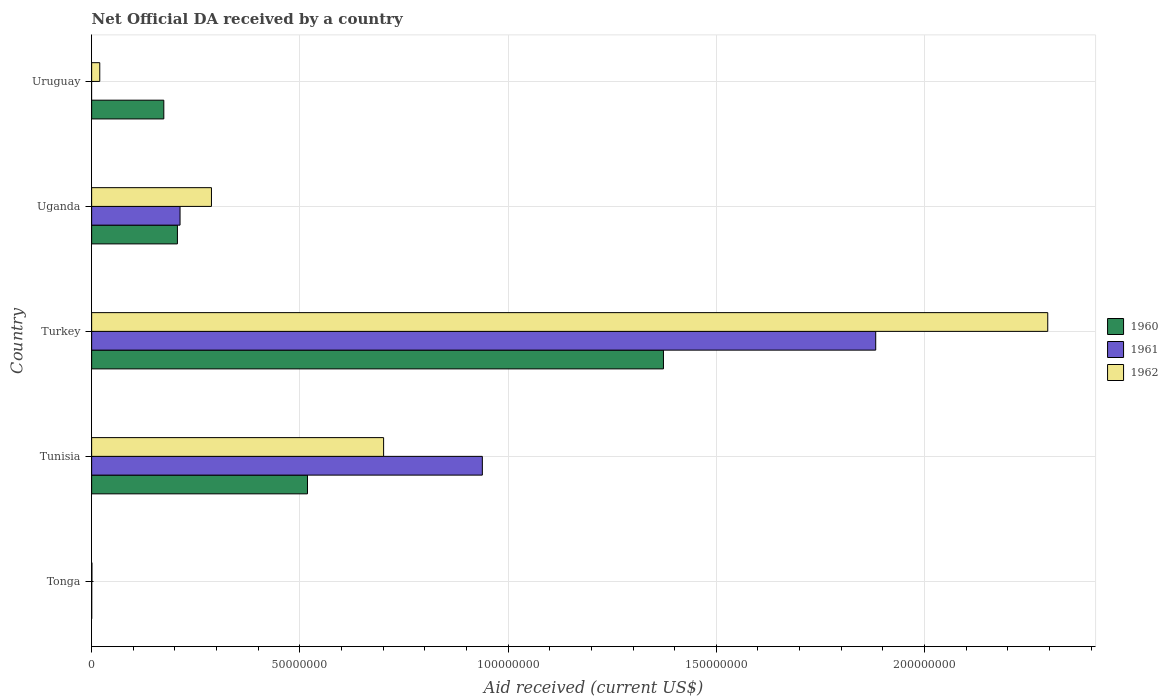Are the number of bars per tick equal to the number of legend labels?
Keep it short and to the point. No. Are the number of bars on each tick of the Y-axis equal?
Give a very brief answer. No. How many bars are there on the 2nd tick from the bottom?
Offer a very short reply. 3. What is the label of the 1st group of bars from the top?
Provide a succinct answer. Uruguay. What is the net official development assistance aid received in 1961 in Tunisia?
Keep it short and to the point. 9.38e+07. Across all countries, what is the maximum net official development assistance aid received in 1961?
Offer a terse response. 1.88e+08. Across all countries, what is the minimum net official development assistance aid received in 1960?
Offer a very short reply. 10000. In which country was the net official development assistance aid received in 1961 maximum?
Your answer should be compact. Turkey. What is the total net official development assistance aid received in 1962 in the graph?
Keep it short and to the point. 3.30e+08. What is the difference between the net official development assistance aid received in 1962 in Turkey and that in Uruguay?
Provide a succinct answer. 2.28e+08. What is the difference between the net official development assistance aid received in 1961 in Uganda and the net official development assistance aid received in 1962 in Turkey?
Provide a short and direct response. -2.08e+08. What is the average net official development assistance aid received in 1962 per country?
Provide a short and direct response. 6.61e+07. What is the ratio of the net official development assistance aid received in 1960 in Tunisia to that in Uganda?
Provide a succinct answer. 2.52. Is the net official development assistance aid received in 1960 in Tunisia less than that in Uganda?
Make the answer very short. No. What is the difference between the highest and the second highest net official development assistance aid received in 1962?
Your answer should be very brief. 1.59e+08. What is the difference between the highest and the lowest net official development assistance aid received in 1960?
Ensure brevity in your answer.  1.37e+08. In how many countries, is the net official development assistance aid received in 1961 greater than the average net official development assistance aid received in 1961 taken over all countries?
Your answer should be compact. 2. Is it the case that in every country, the sum of the net official development assistance aid received in 1961 and net official development assistance aid received in 1960 is greater than the net official development assistance aid received in 1962?
Provide a short and direct response. No. How many bars are there?
Provide a succinct answer. 14. Are all the bars in the graph horizontal?
Your response must be concise. Yes. What is the difference between two consecutive major ticks on the X-axis?
Provide a short and direct response. 5.00e+07. Where does the legend appear in the graph?
Provide a short and direct response. Center right. How many legend labels are there?
Ensure brevity in your answer.  3. How are the legend labels stacked?
Your response must be concise. Vertical. What is the title of the graph?
Ensure brevity in your answer.  Net Official DA received by a country. Does "1969" appear as one of the legend labels in the graph?
Give a very brief answer. No. What is the label or title of the X-axis?
Give a very brief answer. Aid received (current US$). What is the Aid received (current US$) in 1961 in Tonga?
Offer a very short reply. 2.00e+04. What is the Aid received (current US$) of 1960 in Tunisia?
Give a very brief answer. 5.18e+07. What is the Aid received (current US$) of 1961 in Tunisia?
Offer a very short reply. 9.38e+07. What is the Aid received (current US$) in 1962 in Tunisia?
Provide a succinct answer. 7.01e+07. What is the Aid received (current US$) of 1960 in Turkey?
Your answer should be compact. 1.37e+08. What is the Aid received (current US$) of 1961 in Turkey?
Your response must be concise. 1.88e+08. What is the Aid received (current US$) in 1962 in Turkey?
Offer a terse response. 2.30e+08. What is the Aid received (current US$) in 1960 in Uganda?
Your response must be concise. 2.06e+07. What is the Aid received (current US$) in 1961 in Uganda?
Ensure brevity in your answer.  2.12e+07. What is the Aid received (current US$) of 1962 in Uganda?
Give a very brief answer. 2.88e+07. What is the Aid received (current US$) in 1960 in Uruguay?
Make the answer very short. 1.73e+07. What is the Aid received (current US$) in 1961 in Uruguay?
Provide a succinct answer. 0. What is the Aid received (current US$) in 1962 in Uruguay?
Provide a short and direct response. 1.95e+06. Across all countries, what is the maximum Aid received (current US$) of 1960?
Provide a short and direct response. 1.37e+08. Across all countries, what is the maximum Aid received (current US$) of 1961?
Give a very brief answer. 1.88e+08. Across all countries, what is the maximum Aid received (current US$) in 1962?
Provide a succinct answer. 2.30e+08. Across all countries, what is the minimum Aid received (current US$) in 1960?
Your response must be concise. 10000. Across all countries, what is the minimum Aid received (current US$) in 1962?
Provide a succinct answer. 7.00e+04. What is the total Aid received (current US$) in 1960 in the graph?
Offer a terse response. 2.27e+08. What is the total Aid received (current US$) in 1961 in the graph?
Keep it short and to the point. 3.03e+08. What is the total Aid received (current US$) of 1962 in the graph?
Ensure brevity in your answer.  3.30e+08. What is the difference between the Aid received (current US$) of 1960 in Tonga and that in Tunisia?
Keep it short and to the point. -5.18e+07. What is the difference between the Aid received (current US$) of 1961 in Tonga and that in Tunisia?
Provide a succinct answer. -9.38e+07. What is the difference between the Aid received (current US$) in 1962 in Tonga and that in Tunisia?
Your answer should be compact. -7.00e+07. What is the difference between the Aid received (current US$) in 1960 in Tonga and that in Turkey?
Keep it short and to the point. -1.37e+08. What is the difference between the Aid received (current US$) in 1961 in Tonga and that in Turkey?
Offer a terse response. -1.88e+08. What is the difference between the Aid received (current US$) in 1962 in Tonga and that in Turkey?
Provide a short and direct response. -2.30e+08. What is the difference between the Aid received (current US$) of 1960 in Tonga and that in Uganda?
Offer a very short reply. -2.06e+07. What is the difference between the Aid received (current US$) in 1961 in Tonga and that in Uganda?
Offer a very short reply. -2.12e+07. What is the difference between the Aid received (current US$) of 1962 in Tonga and that in Uganda?
Your response must be concise. -2.87e+07. What is the difference between the Aid received (current US$) in 1960 in Tonga and that in Uruguay?
Your answer should be very brief. -1.73e+07. What is the difference between the Aid received (current US$) of 1962 in Tonga and that in Uruguay?
Keep it short and to the point. -1.88e+06. What is the difference between the Aid received (current US$) of 1960 in Tunisia and that in Turkey?
Make the answer very short. -8.55e+07. What is the difference between the Aid received (current US$) of 1961 in Tunisia and that in Turkey?
Offer a terse response. -9.45e+07. What is the difference between the Aid received (current US$) in 1962 in Tunisia and that in Turkey?
Offer a very short reply. -1.59e+08. What is the difference between the Aid received (current US$) in 1960 in Tunisia and that in Uganda?
Provide a short and direct response. 3.12e+07. What is the difference between the Aid received (current US$) in 1961 in Tunisia and that in Uganda?
Offer a terse response. 7.26e+07. What is the difference between the Aid received (current US$) of 1962 in Tunisia and that in Uganda?
Keep it short and to the point. 4.13e+07. What is the difference between the Aid received (current US$) of 1960 in Tunisia and that in Uruguay?
Your answer should be compact. 3.45e+07. What is the difference between the Aid received (current US$) of 1962 in Tunisia and that in Uruguay?
Provide a short and direct response. 6.82e+07. What is the difference between the Aid received (current US$) in 1960 in Turkey and that in Uganda?
Ensure brevity in your answer.  1.17e+08. What is the difference between the Aid received (current US$) in 1961 in Turkey and that in Uganda?
Provide a succinct answer. 1.67e+08. What is the difference between the Aid received (current US$) of 1962 in Turkey and that in Uganda?
Your response must be concise. 2.01e+08. What is the difference between the Aid received (current US$) of 1960 in Turkey and that in Uruguay?
Offer a very short reply. 1.20e+08. What is the difference between the Aid received (current US$) in 1962 in Turkey and that in Uruguay?
Ensure brevity in your answer.  2.28e+08. What is the difference between the Aid received (current US$) of 1960 in Uganda and that in Uruguay?
Your answer should be very brief. 3.27e+06. What is the difference between the Aid received (current US$) in 1962 in Uganda and that in Uruguay?
Provide a succinct answer. 2.68e+07. What is the difference between the Aid received (current US$) of 1960 in Tonga and the Aid received (current US$) of 1961 in Tunisia?
Your answer should be very brief. -9.38e+07. What is the difference between the Aid received (current US$) in 1960 in Tonga and the Aid received (current US$) in 1962 in Tunisia?
Make the answer very short. -7.01e+07. What is the difference between the Aid received (current US$) of 1961 in Tonga and the Aid received (current US$) of 1962 in Tunisia?
Offer a very short reply. -7.01e+07. What is the difference between the Aid received (current US$) in 1960 in Tonga and the Aid received (current US$) in 1961 in Turkey?
Your response must be concise. -1.88e+08. What is the difference between the Aid received (current US$) of 1960 in Tonga and the Aid received (current US$) of 1962 in Turkey?
Your answer should be very brief. -2.30e+08. What is the difference between the Aid received (current US$) in 1961 in Tonga and the Aid received (current US$) in 1962 in Turkey?
Your response must be concise. -2.30e+08. What is the difference between the Aid received (current US$) in 1960 in Tonga and the Aid received (current US$) in 1961 in Uganda?
Your answer should be compact. -2.12e+07. What is the difference between the Aid received (current US$) in 1960 in Tonga and the Aid received (current US$) in 1962 in Uganda?
Provide a short and direct response. -2.88e+07. What is the difference between the Aid received (current US$) in 1961 in Tonga and the Aid received (current US$) in 1962 in Uganda?
Provide a succinct answer. -2.88e+07. What is the difference between the Aid received (current US$) of 1960 in Tonga and the Aid received (current US$) of 1962 in Uruguay?
Your response must be concise. -1.94e+06. What is the difference between the Aid received (current US$) of 1961 in Tonga and the Aid received (current US$) of 1962 in Uruguay?
Ensure brevity in your answer.  -1.93e+06. What is the difference between the Aid received (current US$) in 1960 in Tunisia and the Aid received (current US$) in 1961 in Turkey?
Your answer should be compact. -1.36e+08. What is the difference between the Aid received (current US$) of 1960 in Tunisia and the Aid received (current US$) of 1962 in Turkey?
Offer a very short reply. -1.78e+08. What is the difference between the Aid received (current US$) of 1961 in Tunisia and the Aid received (current US$) of 1962 in Turkey?
Provide a short and direct response. -1.36e+08. What is the difference between the Aid received (current US$) of 1960 in Tunisia and the Aid received (current US$) of 1961 in Uganda?
Offer a terse response. 3.06e+07. What is the difference between the Aid received (current US$) of 1960 in Tunisia and the Aid received (current US$) of 1962 in Uganda?
Provide a short and direct response. 2.31e+07. What is the difference between the Aid received (current US$) of 1961 in Tunisia and the Aid received (current US$) of 1962 in Uganda?
Your answer should be compact. 6.50e+07. What is the difference between the Aid received (current US$) of 1960 in Tunisia and the Aid received (current US$) of 1962 in Uruguay?
Your response must be concise. 4.99e+07. What is the difference between the Aid received (current US$) in 1961 in Tunisia and the Aid received (current US$) in 1962 in Uruguay?
Keep it short and to the point. 9.19e+07. What is the difference between the Aid received (current US$) in 1960 in Turkey and the Aid received (current US$) in 1961 in Uganda?
Provide a succinct answer. 1.16e+08. What is the difference between the Aid received (current US$) of 1960 in Turkey and the Aid received (current US$) of 1962 in Uganda?
Ensure brevity in your answer.  1.09e+08. What is the difference between the Aid received (current US$) of 1961 in Turkey and the Aid received (current US$) of 1962 in Uganda?
Offer a terse response. 1.60e+08. What is the difference between the Aid received (current US$) in 1960 in Turkey and the Aid received (current US$) in 1962 in Uruguay?
Offer a very short reply. 1.35e+08. What is the difference between the Aid received (current US$) of 1961 in Turkey and the Aid received (current US$) of 1962 in Uruguay?
Make the answer very short. 1.86e+08. What is the difference between the Aid received (current US$) in 1960 in Uganda and the Aid received (current US$) in 1962 in Uruguay?
Your answer should be very brief. 1.86e+07. What is the difference between the Aid received (current US$) of 1961 in Uganda and the Aid received (current US$) of 1962 in Uruguay?
Offer a terse response. 1.93e+07. What is the average Aid received (current US$) of 1960 per country?
Keep it short and to the point. 4.54e+07. What is the average Aid received (current US$) in 1961 per country?
Provide a short and direct response. 6.07e+07. What is the average Aid received (current US$) of 1962 per country?
Your response must be concise. 6.61e+07. What is the difference between the Aid received (current US$) of 1960 and Aid received (current US$) of 1961 in Tonga?
Your response must be concise. -10000. What is the difference between the Aid received (current US$) in 1960 and Aid received (current US$) in 1962 in Tonga?
Offer a very short reply. -6.00e+04. What is the difference between the Aid received (current US$) of 1960 and Aid received (current US$) of 1961 in Tunisia?
Offer a terse response. -4.20e+07. What is the difference between the Aid received (current US$) in 1960 and Aid received (current US$) in 1962 in Tunisia?
Offer a very short reply. -1.83e+07. What is the difference between the Aid received (current US$) in 1961 and Aid received (current US$) in 1962 in Tunisia?
Ensure brevity in your answer.  2.37e+07. What is the difference between the Aid received (current US$) of 1960 and Aid received (current US$) of 1961 in Turkey?
Ensure brevity in your answer.  -5.10e+07. What is the difference between the Aid received (current US$) in 1960 and Aid received (current US$) in 1962 in Turkey?
Offer a very short reply. -9.23e+07. What is the difference between the Aid received (current US$) in 1961 and Aid received (current US$) in 1962 in Turkey?
Your response must be concise. -4.13e+07. What is the difference between the Aid received (current US$) of 1960 and Aid received (current US$) of 1961 in Uganda?
Keep it short and to the point. -6.30e+05. What is the difference between the Aid received (current US$) in 1960 and Aid received (current US$) in 1962 in Uganda?
Make the answer very short. -8.17e+06. What is the difference between the Aid received (current US$) of 1961 and Aid received (current US$) of 1962 in Uganda?
Ensure brevity in your answer.  -7.54e+06. What is the difference between the Aid received (current US$) of 1960 and Aid received (current US$) of 1962 in Uruguay?
Your response must be concise. 1.54e+07. What is the ratio of the Aid received (current US$) of 1960 in Tonga to that in Tunisia?
Provide a succinct answer. 0. What is the ratio of the Aid received (current US$) of 1961 in Tonga to that in Tunisia?
Offer a terse response. 0. What is the ratio of the Aid received (current US$) of 1960 in Tonga to that in Uganda?
Your answer should be very brief. 0. What is the ratio of the Aid received (current US$) of 1961 in Tonga to that in Uganda?
Your response must be concise. 0. What is the ratio of the Aid received (current US$) of 1962 in Tonga to that in Uganda?
Make the answer very short. 0. What is the ratio of the Aid received (current US$) in 1960 in Tonga to that in Uruguay?
Give a very brief answer. 0. What is the ratio of the Aid received (current US$) in 1962 in Tonga to that in Uruguay?
Your answer should be very brief. 0.04. What is the ratio of the Aid received (current US$) in 1960 in Tunisia to that in Turkey?
Your answer should be compact. 0.38. What is the ratio of the Aid received (current US$) in 1961 in Tunisia to that in Turkey?
Provide a succinct answer. 0.5. What is the ratio of the Aid received (current US$) of 1962 in Tunisia to that in Turkey?
Keep it short and to the point. 0.31. What is the ratio of the Aid received (current US$) in 1960 in Tunisia to that in Uganda?
Provide a short and direct response. 2.52. What is the ratio of the Aid received (current US$) in 1961 in Tunisia to that in Uganda?
Your answer should be compact. 4.42. What is the ratio of the Aid received (current US$) in 1962 in Tunisia to that in Uganda?
Your response must be concise. 2.44. What is the ratio of the Aid received (current US$) of 1960 in Tunisia to that in Uruguay?
Your response must be concise. 2.99. What is the ratio of the Aid received (current US$) in 1962 in Tunisia to that in Uruguay?
Your answer should be compact. 35.95. What is the ratio of the Aid received (current US$) in 1960 in Turkey to that in Uganda?
Your answer should be very brief. 6.67. What is the ratio of the Aid received (current US$) of 1961 in Turkey to that in Uganda?
Your response must be concise. 8.87. What is the ratio of the Aid received (current US$) of 1962 in Turkey to that in Uganda?
Keep it short and to the point. 7.98. What is the ratio of the Aid received (current US$) of 1960 in Turkey to that in Uruguay?
Ensure brevity in your answer.  7.92. What is the ratio of the Aid received (current US$) of 1962 in Turkey to that in Uruguay?
Offer a very short reply. 117.74. What is the ratio of the Aid received (current US$) of 1960 in Uganda to that in Uruguay?
Ensure brevity in your answer.  1.19. What is the ratio of the Aid received (current US$) in 1962 in Uganda to that in Uruguay?
Keep it short and to the point. 14.75. What is the difference between the highest and the second highest Aid received (current US$) of 1960?
Ensure brevity in your answer.  8.55e+07. What is the difference between the highest and the second highest Aid received (current US$) in 1961?
Provide a short and direct response. 9.45e+07. What is the difference between the highest and the second highest Aid received (current US$) of 1962?
Give a very brief answer. 1.59e+08. What is the difference between the highest and the lowest Aid received (current US$) in 1960?
Ensure brevity in your answer.  1.37e+08. What is the difference between the highest and the lowest Aid received (current US$) in 1961?
Provide a succinct answer. 1.88e+08. What is the difference between the highest and the lowest Aid received (current US$) of 1962?
Provide a short and direct response. 2.30e+08. 